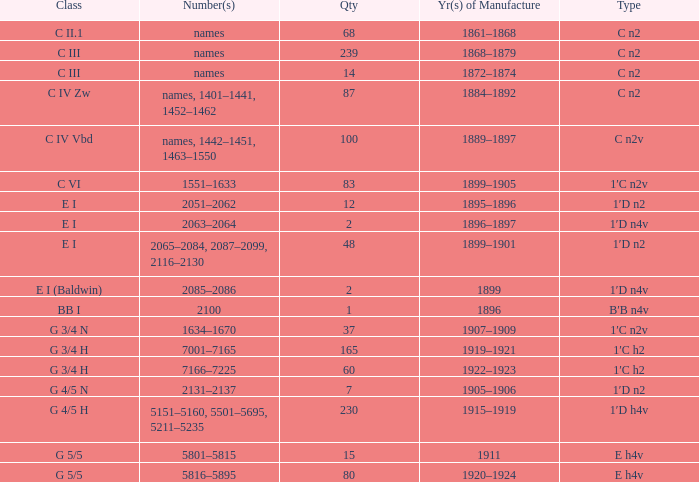I'm looking to parse the entire table for insights. Could you assist me with that? {'header': ['Class', 'Number(s)', 'Qty', 'Yr(s) of Manufacture', 'Type'], 'rows': [['C II.1', 'names', '68', '1861–1868', 'C n2'], ['C III', 'names', '239', '1868–1879', 'C n2'], ['C III', 'names', '14', '1872–1874', 'C n2'], ['C IV Zw', 'names, 1401–1441, 1452–1462', '87', '1884–1892', 'C n2'], ['C IV Vbd', 'names, 1442–1451, 1463–1550', '100', '1889–1897', 'C n2v'], ['C VI', '1551–1633', '83', '1899–1905', '1′C n2v'], ['E I', '2051–2062', '12', '1895–1896', '1′D n2'], ['E I', '2063–2064', '2', '1896–1897', '1′D n4v'], ['E I', '2065–2084, 2087–2099, 2116–2130', '48', '1899–1901', '1′D n2'], ['E I (Baldwin)', '2085–2086', '2', '1899', '1′D n4v'], ['BB I', '2100', '1', '1896', 'B′B n4v'], ['G 3/4 N', '1634–1670', '37', '1907–1909', '1′C n2v'], ['G 3/4 H', '7001–7165', '165', '1919–1921', '1′C h2'], ['G 3/4 H', '7166–7225', '60', '1922–1923', '1′C h2'], ['G 4/5 N', '2131–2137', '7', '1905–1906', '1′D n2'], ['G 4/5 H', '5151–5160, 5501–5695, 5211–5235', '230', '1915–1919', '1′D h4v'], ['G 5/5', '5801–5815', '15', '1911', 'E h4v'], ['G 5/5', '5816–5895', '80', '1920–1924', 'E h4v']]} Which Class has a Year(s) of Manufacture of 1899? E I (Baldwin). 